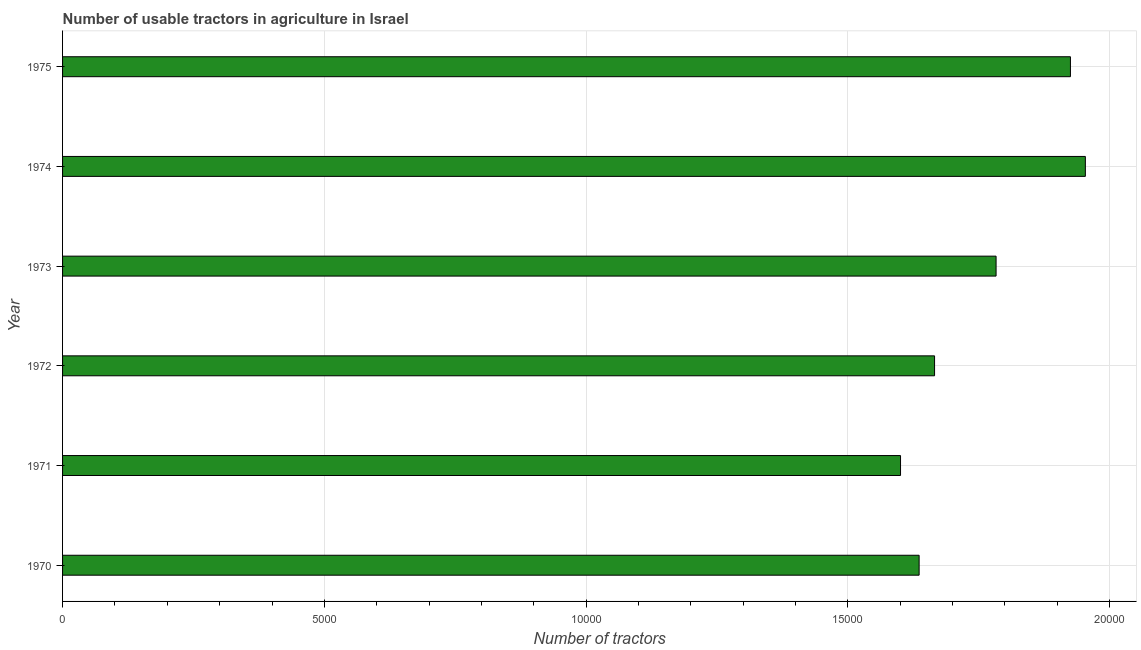Does the graph contain any zero values?
Ensure brevity in your answer.  No. What is the title of the graph?
Provide a succinct answer. Number of usable tractors in agriculture in Israel. What is the label or title of the X-axis?
Make the answer very short. Number of tractors. What is the label or title of the Y-axis?
Your response must be concise. Year. What is the number of tractors in 1974?
Your response must be concise. 1.95e+04. Across all years, what is the maximum number of tractors?
Your answer should be very brief. 1.95e+04. Across all years, what is the minimum number of tractors?
Provide a succinct answer. 1.60e+04. In which year was the number of tractors maximum?
Provide a short and direct response. 1974. What is the sum of the number of tractors?
Your answer should be very brief. 1.06e+05. What is the difference between the number of tractors in 1974 and 1975?
Keep it short and to the point. 285. What is the average number of tractors per year?
Ensure brevity in your answer.  1.76e+04. What is the median number of tractors?
Provide a short and direct response. 1.72e+04. In how many years, is the number of tractors greater than 13000 ?
Keep it short and to the point. 6. What is the ratio of the number of tractors in 1970 to that in 1974?
Make the answer very short. 0.84. Is the number of tractors in 1972 less than that in 1975?
Provide a succinct answer. Yes. Is the difference between the number of tractors in 1971 and 1973 greater than the difference between any two years?
Make the answer very short. No. What is the difference between the highest and the second highest number of tractors?
Offer a terse response. 285. Is the sum of the number of tractors in 1971 and 1975 greater than the maximum number of tractors across all years?
Your response must be concise. Yes. What is the difference between the highest and the lowest number of tractors?
Make the answer very short. 3530. How many bars are there?
Your response must be concise. 6. How many years are there in the graph?
Ensure brevity in your answer.  6. What is the Number of tractors in 1970?
Provide a short and direct response. 1.64e+04. What is the Number of tractors in 1971?
Ensure brevity in your answer.  1.60e+04. What is the Number of tractors in 1972?
Ensure brevity in your answer.  1.67e+04. What is the Number of tractors of 1973?
Provide a short and direct response. 1.78e+04. What is the Number of tractors in 1974?
Offer a terse response. 1.95e+04. What is the Number of tractors of 1975?
Your answer should be compact. 1.92e+04. What is the difference between the Number of tractors in 1970 and 1971?
Provide a succinct answer. 355. What is the difference between the Number of tractors in 1970 and 1972?
Your answer should be very brief. -295. What is the difference between the Number of tractors in 1970 and 1973?
Your answer should be compact. -1470. What is the difference between the Number of tractors in 1970 and 1974?
Offer a terse response. -3175. What is the difference between the Number of tractors in 1970 and 1975?
Your response must be concise. -2890. What is the difference between the Number of tractors in 1971 and 1972?
Offer a very short reply. -650. What is the difference between the Number of tractors in 1971 and 1973?
Provide a succinct answer. -1825. What is the difference between the Number of tractors in 1971 and 1974?
Keep it short and to the point. -3530. What is the difference between the Number of tractors in 1971 and 1975?
Your response must be concise. -3245. What is the difference between the Number of tractors in 1972 and 1973?
Ensure brevity in your answer.  -1175. What is the difference between the Number of tractors in 1972 and 1974?
Offer a very short reply. -2880. What is the difference between the Number of tractors in 1972 and 1975?
Your answer should be very brief. -2595. What is the difference between the Number of tractors in 1973 and 1974?
Provide a short and direct response. -1705. What is the difference between the Number of tractors in 1973 and 1975?
Your response must be concise. -1420. What is the difference between the Number of tractors in 1974 and 1975?
Your response must be concise. 285. What is the ratio of the Number of tractors in 1970 to that in 1971?
Provide a short and direct response. 1.02. What is the ratio of the Number of tractors in 1970 to that in 1973?
Offer a terse response. 0.92. What is the ratio of the Number of tractors in 1970 to that in 1974?
Keep it short and to the point. 0.84. What is the ratio of the Number of tractors in 1970 to that in 1975?
Give a very brief answer. 0.85. What is the ratio of the Number of tractors in 1971 to that in 1972?
Provide a short and direct response. 0.96. What is the ratio of the Number of tractors in 1971 to that in 1973?
Ensure brevity in your answer.  0.9. What is the ratio of the Number of tractors in 1971 to that in 1974?
Make the answer very short. 0.82. What is the ratio of the Number of tractors in 1971 to that in 1975?
Provide a short and direct response. 0.83. What is the ratio of the Number of tractors in 1972 to that in 1973?
Your response must be concise. 0.93. What is the ratio of the Number of tractors in 1972 to that in 1974?
Give a very brief answer. 0.85. What is the ratio of the Number of tractors in 1972 to that in 1975?
Keep it short and to the point. 0.86. What is the ratio of the Number of tractors in 1973 to that in 1974?
Ensure brevity in your answer.  0.91. What is the ratio of the Number of tractors in 1973 to that in 1975?
Make the answer very short. 0.93. What is the ratio of the Number of tractors in 1974 to that in 1975?
Ensure brevity in your answer.  1.01. 